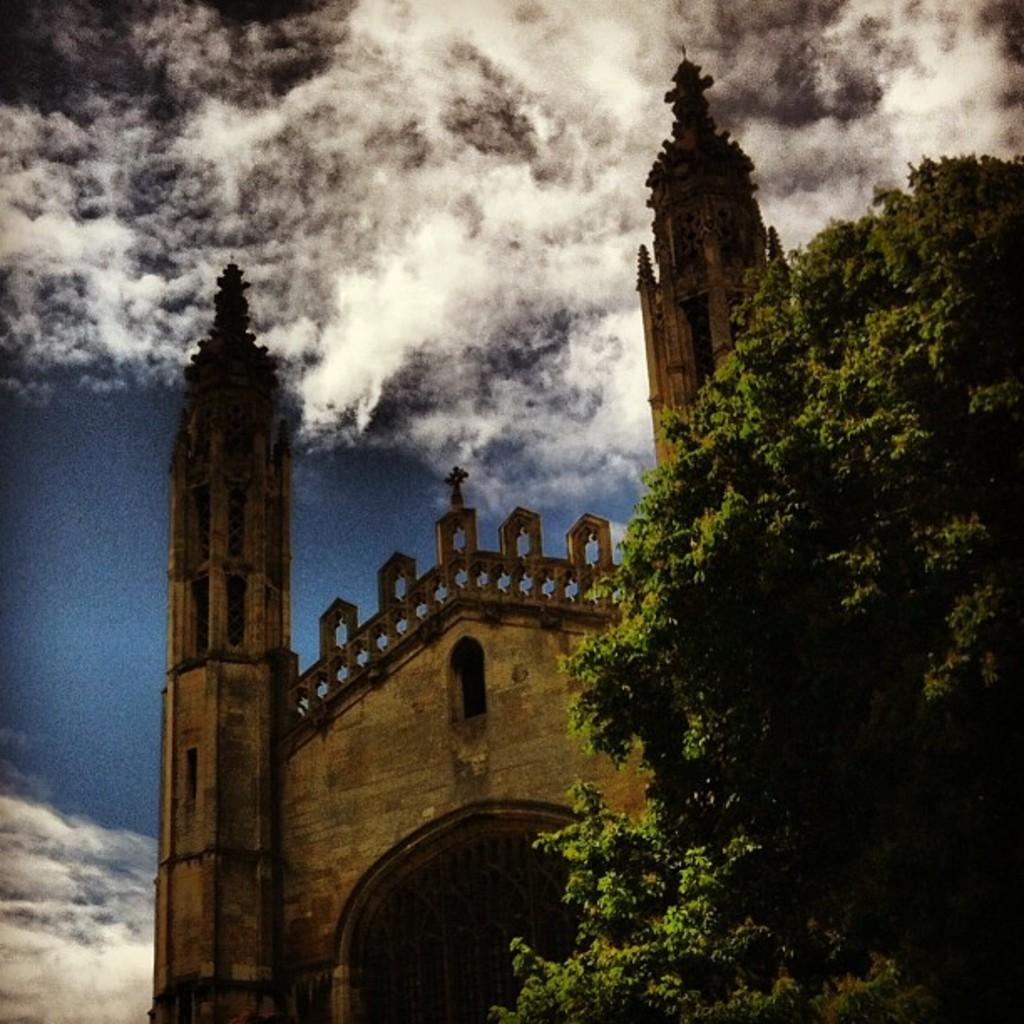What type of structure is visible in the image? There is a building in the image. What can be seen on the right side of the image? There is a tree on the right side of the image. What is visible in the background of the image? The sky is visible in the background of the image. What is present in the sky? Clouds are present in the sky. How many letters are visible on the blade in the image? There is no blade or letters present in the image. 